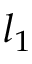<formula> <loc_0><loc_0><loc_500><loc_500>l _ { 1 }</formula> 